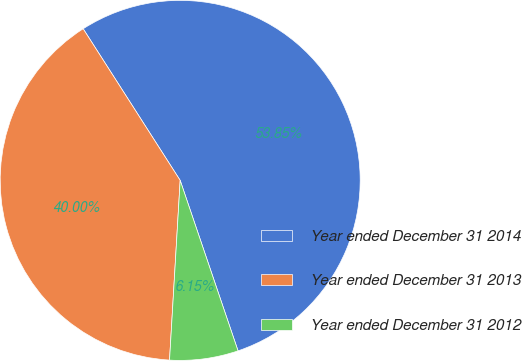<chart> <loc_0><loc_0><loc_500><loc_500><pie_chart><fcel>Year ended December 31 2014<fcel>Year ended December 31 2013<fcel>Year ended December 31 2012<nl><fcel>53.85%<fcel>40.0%<fcel>6.15%<nl></chart> 